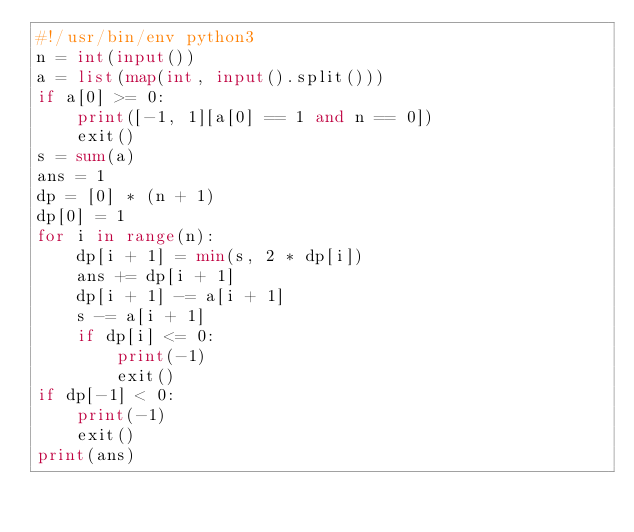<code> <loc_0><loc_0><loc_500><loc_500><_Python_>#!/usr/bin/env python3
n = int(input())
a = list(map(int, input().split()))
if a[0] >= 0:
    print([-1, 1][a[0] == 1 and n == 0])
    exit()
s = sum(a)
ans = 1
dp = [0] * (n + 1)
dp[0] = 1
for i in range(n):
    dp[i + 1] = min(s, 2 * dp[i])
    ans += dp[i + 1]
    dp[i + 1] -= a[i + 1]
    s -= a[i + 1]
    if dp[i] <= 0:
        print(-1)
        exit()
if dp[-1] < 0:
    print(-1)
    exit()
print(ans)
</code> 